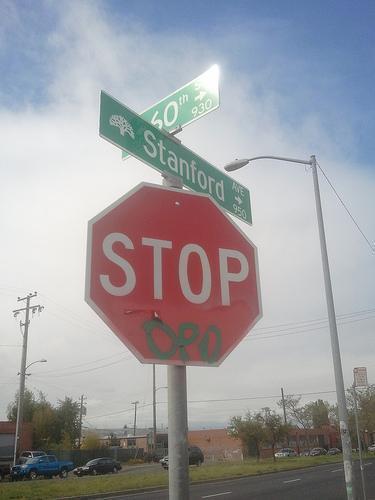How many stop signs are there?
Give a very brief answer. 1. How many blue trucks are there?
Give a very brief answer. 1. 